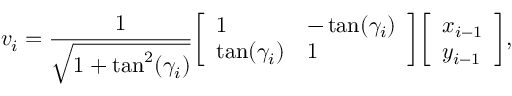<formula> <loc_0><loc_0><loc_500><loc_500>v _ { i } = { \frac { 1 } { \sqrt { 1 + \tan ^ { 2 } ( \gamma _ { i } ) } } } { \left [ \begin{array} { l l } { 1 } & { - \tan ( \gamma _ { i } ) } \\ { \tan ( \gamma _ { i } ) } & { 1 } \end{array} \right ] } { \left [ \begin{array} { l } { x _ { i - 1 } } \\ { y _ { i - 1 } } \end{array} \right ] } ,</formula> 